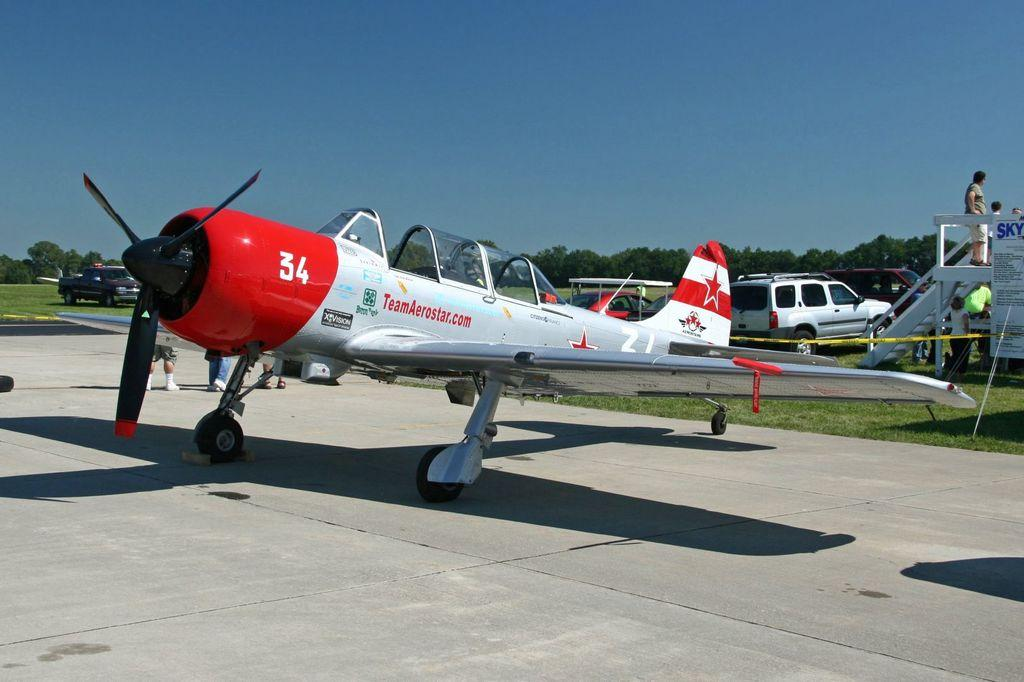<image>
Create a compact narrative representing the image presented. teamaerostar.com has a red and white plane sitting here 